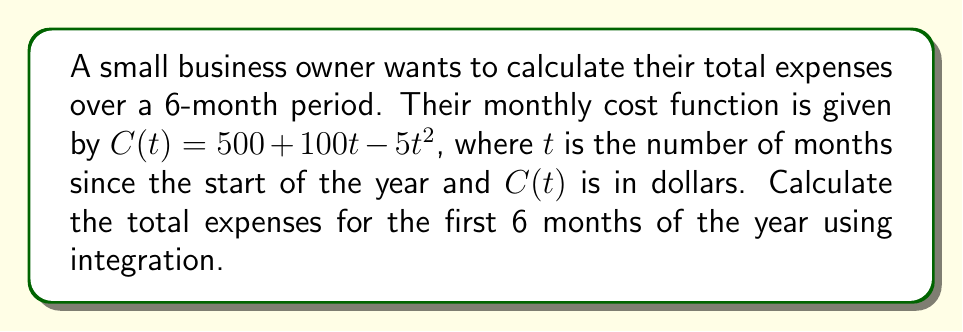Help me with this question. To find the total expenses over the 6-month period, we need to calculate the area under the cost curve from $t=0$ to $t=6$. This can be done using definite integration.

1) The integral we need to evaluate is:

   $$\int_0^6 (500 + 100t - 5t^2) dt$$

2) Let's integrate each term separately:

   $$\int 500 dt = 500t$$
   $$\int 100t dt = 50t^2$$
   $$\int -5t^2 dt = -\frac{5}{3}t^3$$

3) Combining these, we get:

   $$\int (500 + 100t - 5t^2) dt = 500t + 50t^2 - \frac{5}{3}t^3 + C$$

4) Now, we need to evaluate this from $t=0$ to $t=6$:

   $$[500t + 50t^2 - \frac{5}{3}t^3]_0^6$$

5) Substituting the limits:

   $$(500(6) + 50(6^2) - \frac{5}{3}(6^3)) - (500(0) + 50(0^2) - \frac{5}{3}(0^3))$$

6) Simplifying:

   $$(3000 + 1800 - 720) - 0 = 4080$$

Therefore, the total expenses for the first 6 months are $4,080.
Answer: $4,080 